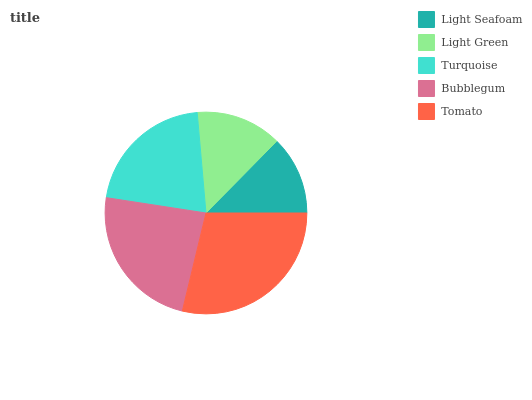Is Light Seafoam the minimum?
Answer yes or no. Yes. Is Tomato the maximum?
Answer yes or no. Yes. Is Light Green the minimum?
Answer yes or no. No. Is Light Green the maximum?
Answer yes or no. No. Is Light Green greater than Light Seafoam?
Answer yes or no. Yes. Is Light Seafoam less than Light Green?
Answer yes or no. Yes. Is Light Seafoam greater than Light Green?
Answer yes or no. No. Is Light Green less than Light Seafoam?
Answer yes or no. No. Is Turquoise the high median?
Answer yes or no. Yes. Is Turquoise the low median?
Answer yes or no. Yes. Is Bubblegum the high median?
Answer yes or no. No. Is Light Green the low median?
Answer yes or no. No. 